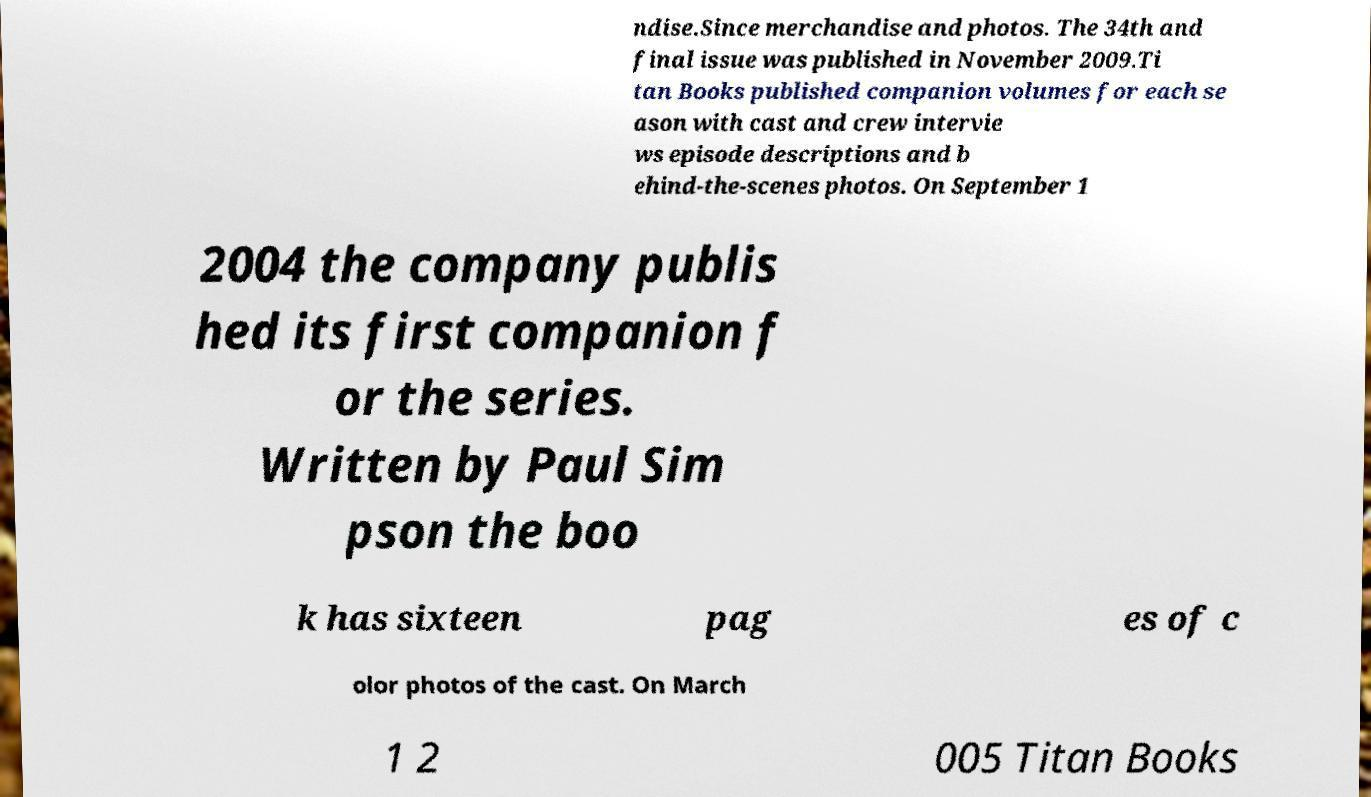Can you accurately transcribe the text from the provided image for me? ndise.Since merchandise and photos. The 34th and final issue was published in November 2009.Ti tan Books published companion volumes for each se ason with cast and crew intervie ws episode descriptions and b ehind-the-scenes photos. On September 1 2004 the company publis hed its first companion f or the series. Written by Paul Sim pson the boo k has sixteen pag es of c olor photos of the cast. On March 1 2 005 Titan Books 